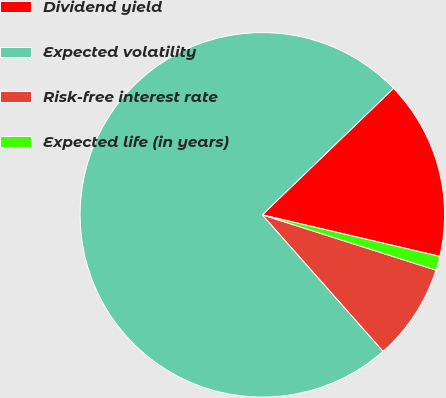Convert chart. <chart><loc_0><loc_0><loc_500><loc_500><pie_chart><fcel>Dividend yield<fcel>Expected volatility<fcel>Risk-free interest rate<fcel>Expected life (in years)<nl><fcel>15.87%<fcel>74.32%<fcel>8.56%<fcel>1.25%<nl></chart> 